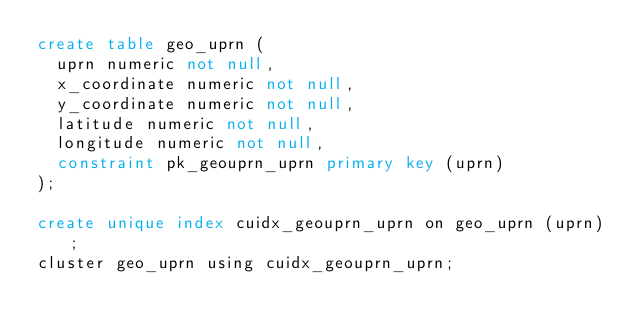Convert code to text. <code><loc_0><loc_0><loc_500><loc_500><_SQL_>create table geo_uprn (
  uprn numeric not null,
  x_coordinate numeric not null,
  y_coordinate numeric not null,
  latitude numeric not null,
  longitude numeric not null,
  constraint pk_geouprn_uprn primary key (uprn)
);

create unique index cuidx_geouprn_uprn on geo_uprn (uprn);
cluster geo_uprn using cuidx_geouprn_uprn;
</code> 